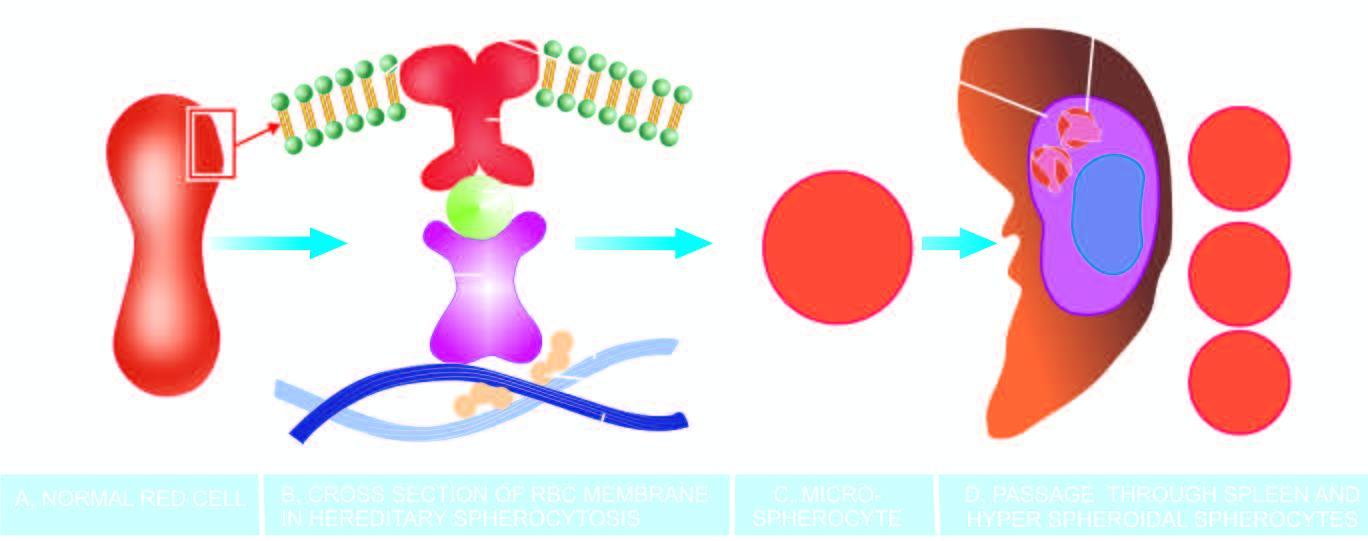does this produce a circulating subpopulation of hyperspheroidal spherocytes while splenic macrophages in large numbers phagocytose defective red cells causing splenomegaly?
Answer the question using a single word or phrase. Yes 